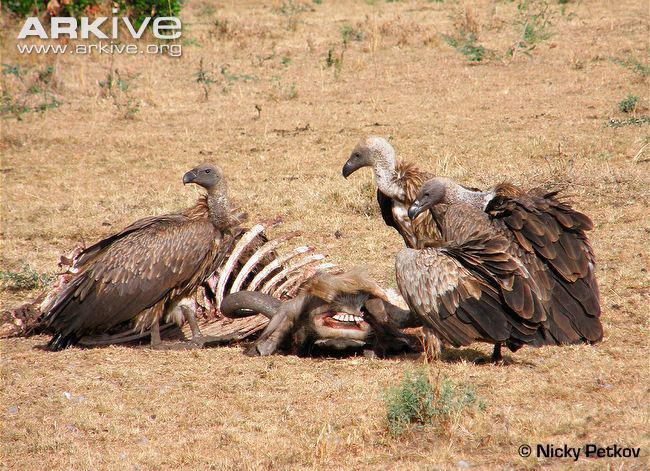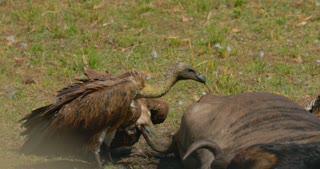The first image is the image on the left, the second image is the image on the right. Examine the images to the left and right. Is the description "Vultures ripping flesh off of bones can be seen in one image." accurate? Answer yes or no. No. 